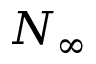Convert formula to latex. <formula><loc_0><loc_0><loc_500><loc_500>N _ { \infty }</formula> 